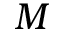Convert formula to latex. <formula><loc_0><loc_0><loc_500><loc_500>M</formula> 